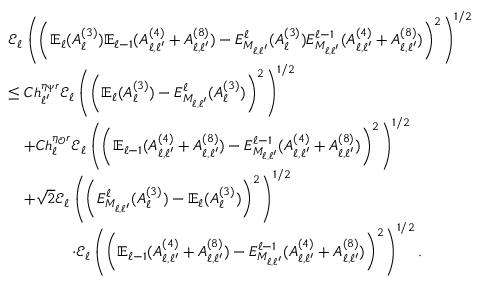<formula> <loc_0><loc_0><loc_500><loc_500>\begin{array} { r l } & { \mathcal { E } _ { \ell } \left ( \left ( \mathbb { E } _ { \ell } ( A _ { \ell } ^ { ( 3 ) } ) \mathbb { E } _ { \ell - 1 } ( A _ { \ell , \ell ^ { \prime } } ^ { ( 4 ) } + A _ { \ell , \ell ^ { \prime } } ^ { ( 8 ) } ) - E _ { M _ { \ell , \ell ^ { \prime } } } ^ { \ell } ( A _ { \ell } ^ { ( 3 ) } ) E _ { M _ { \ell , \ell ^ { \prime } } } ^ { \ell - 1 } ( A _ { \ell , \ell ^ { \prime } } ^ { ( 4 ) } + A _ { \ell , \ell ^ { \prime } } ^ { ( 8 ) } ) \right ) ^ { 2 } \right ) ^ { 1 / 2 } } \\ & { \leq C h _ { \ell ^ { \prime } } ^ { \eta _ { \Psi } r } \mathcal { E } _ { \ell } \left ( \left ( \mathbb { E } _ { \ell } ( A _ { \ell } ^ { ( 3 ) } ) - E _ { M _ { \ell , \ell ^ { \prime } } } ^ { \ell } ( A _ { \ell } ^ { ( 3 ) } ) \right ) ^ { 2 } \right ) ^ { 1 / 2 } } \\ & { \quad + C h _ { \ell } ^ { \eta _ { \mathcal { O } } r } \mathcal { E } _ { \ell } \left ( \left ( \mathbb { E } _ { \ell - 1 } ( A _ { \ell , \ell ^ { \prime } } ^ { ( 4 ) } + A _ { \ell , \ell ^ { \prime } } ^ { ( 8 ) } ) - E _ { M _ { \ell , \ell ^ { \prime } } } ^ { \ell - 1 } ( A _ { \ell , \ell ^ { \prime } } ^ { ( 4 ) } + A _ { \ell , \ell ^ { \prime } } ^ { ( 8 ) } ) \right ) ^ { 2 } \right ) ^ { 1 / 2 } } \\ & { \quad + \sqrt { 2 } \mathcal { E } _ { \ell } \left ( \left ( E _ { M _ { \ell , \ell ^ { \prime } } } ^ { \ell } ( A _ { \ell } ^ { ( 3 ) } ) - \mathbb { E } _ { \ell } ( A _ { \ell } ^ { ( 3 ) } ) \right ) ^ { 2 } \right ) ^ { 1 / 2 } } \\ & { \quad \cdot \mathcal { E } _ { \ell } \left ( \left ( \mathbb { E } _ { \ell - 1 } ( A _ { \ell , \ell ^ { \prime } } ^ { ( 4 ) } + A _ { \ell , \ell ^ { \prime } } ^ { ( 8 ) } ) - E _ { M _ { \ell , \ell ^ { \prime } } } ^ { \ell - 1 } ( A _ { \ell , \ell ^ { \prime } } ^ { ( 4 ) } + A _ { \ell , \ell ^ { \prime } } ^ { ( 8 ) } ) \right ) ^ { 2 } \right ) ^ { 1 / 2 } . } \end{array}</formula> 